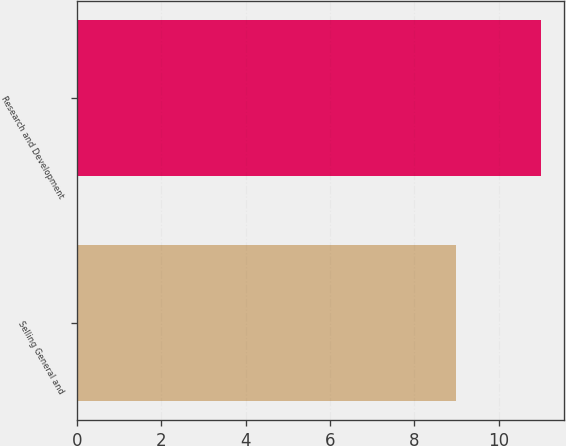Convert chart to OTSL. <chart><loc_0><loc_0><loc_500><loc_500><bar_chart><fcel>Selling General and<fcel>Research and Development<nl><fcel>9<fcel>11<nl></chart> 